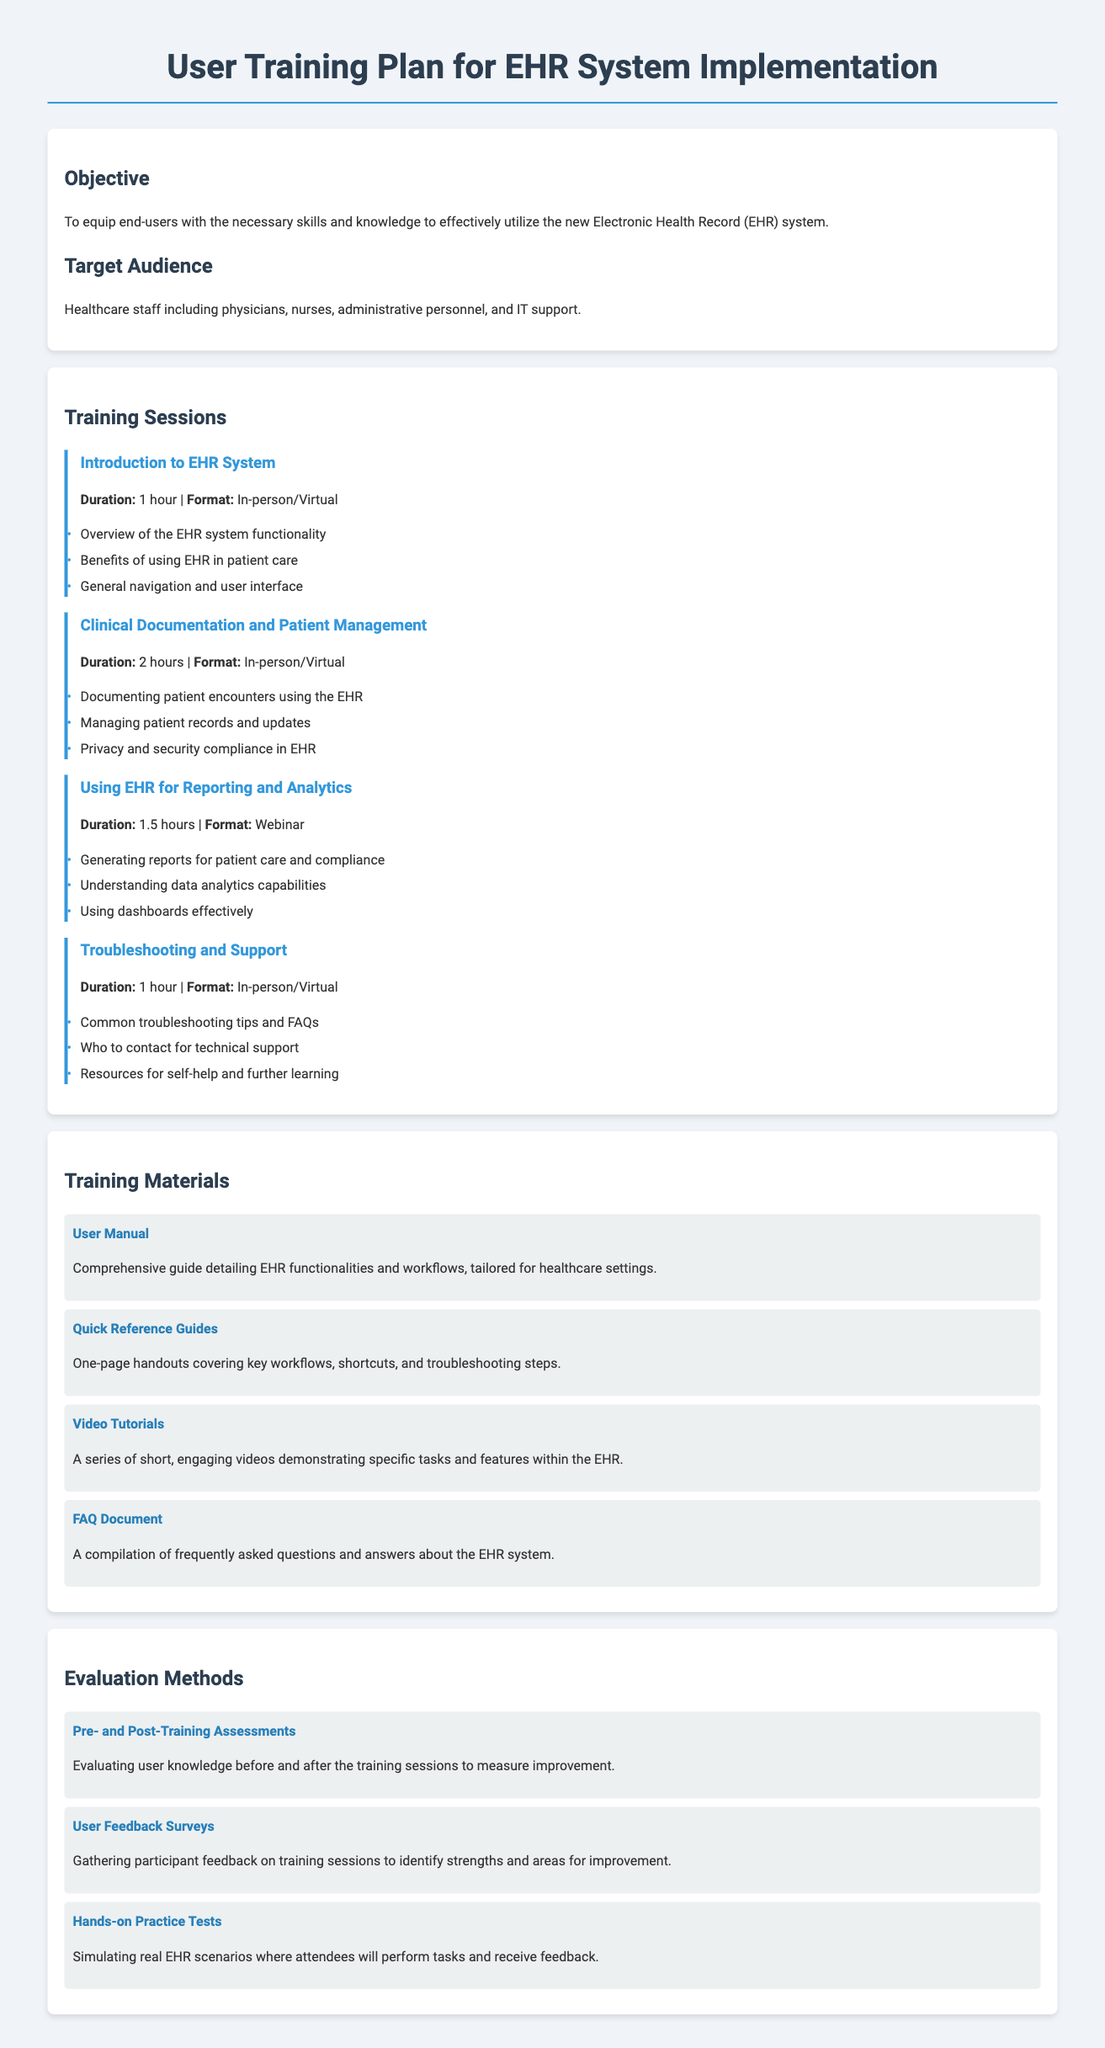what is the objective of the training plan? The objective is to equip end-users with the necessary skills and knowledge to effectively utilize the new Electronic Health Record (EHR) system.
Answer: equip end-users who is the target audience for the training sessions? The target audience includes healthcare staff such as physicians, nurses, administrative personnel, and IT support.
Answer: healthcare staff how long is the "Clinical Documentation and Patient Management" session? The duration of the "Clinical Documentation and Patient Management" session is mentioned in the document as 2 hours.
Answer: 2 hours what materials are included in the training plan? The training materials are listed in the document, which includes the User Manual, Quick Reference Guides, Video Tutorials, and FAQ Document.
Answer: User Manual, Quick Reference Guides, Video Tutorials, FAQ Document what evaluation method involves user feedback? The evaluation method that involves user feedback is the User Feedback Surveys, which gather participant feedback on training sessions.
Answer: User Feedback Surveys what is one of the hands-on evaluation methods mentioned? The document mentions Hands-on Practice Tests as one of the evaluation methods where attendees will perform tasks and receive feedback.
Answer: Hands-on Practice Tests how many training sessions are listed in the document? The document lists a total of four training sessions for the EHR system.
Answer: four what is the duration of the "Introduction to EHR System" session? The duration of the "Introduction to EHR System" session is specified as 1 hour.
Answer: 1 hour 